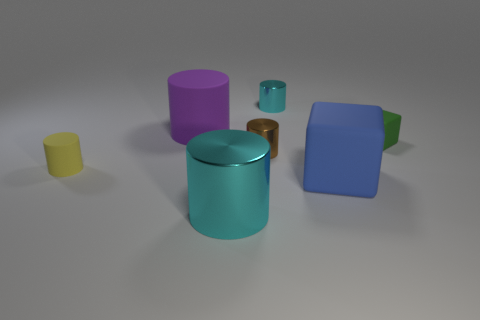Subtract all purple cylinders. How many cylinders are left? 4 Subtract all big cyan cylinders. How many cylinders are left? 4 Subtract all gray blocks. Subtract all green balls. How many blocks are left? 2 Add 3 large purple rubber blocks. How many objects exist? 10 Subtract all cubes. How many objects are left? 5 Subtract all tiny brown cylinders. Subtract all small shiny objects. How many objects are left? 4 Add 6 yellow rubber cylinders. How many yellow rubber cylinders are left? 7 Add 3 gray rubber cylinders. How many gray rubber cylinders exist? 3 Subtract 1 brown cylinders. How many objects are left? 6 